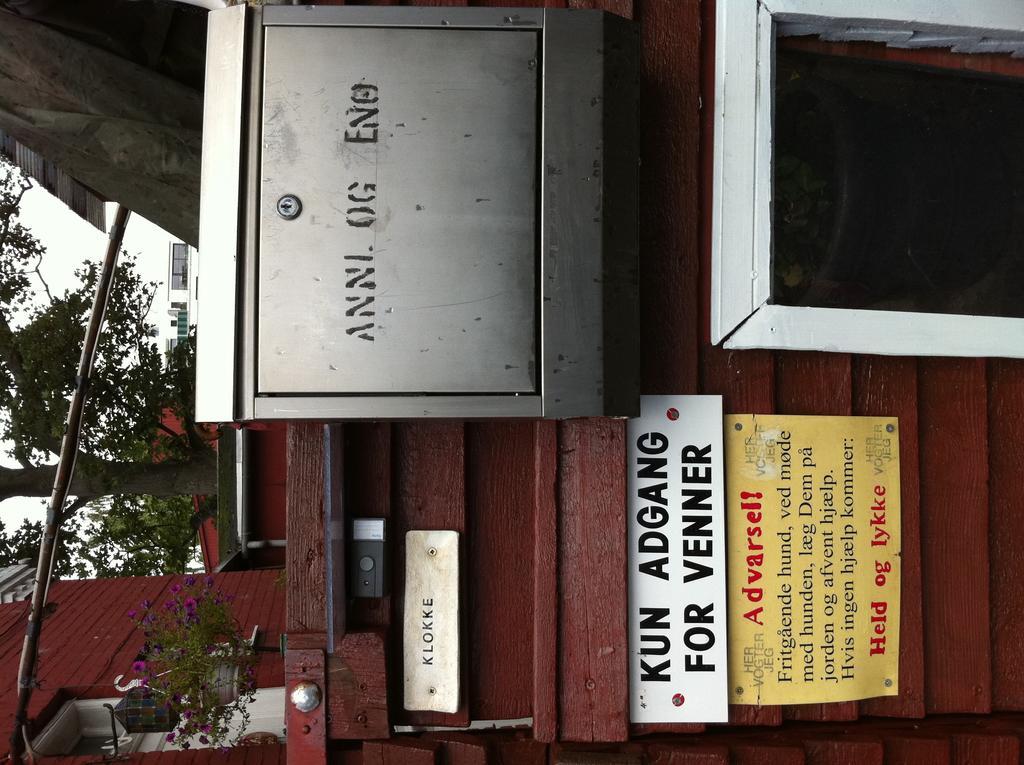Can you describe this image briefly? We can see locker and boards on wooden surface. In the background we can see plant with pot, flowers, lights, houses, tree and sky. 